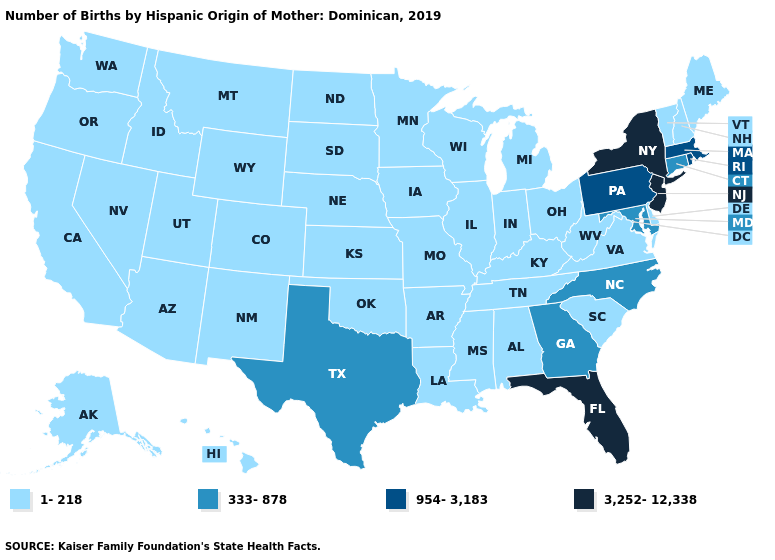Is the legend a continuous bar?
Give a very brief answer. No. Name the states that have a value in the range 954-3,183?
Answer briefly. Massachusetts, Pennsylvania, Rhode Island. What is the value of Oregon?
Be succinct. 1-218. Name the states that have a value in the range 1-218?
Answer briefly. Alabama, Alaska, Arizona, Arkansas, California, Colorado, Delaware, Hawaii, Idaho, Illinois, Indiana, Iowa, Kansas, Kentucky, Louisiana, Maine, Michigan, Minnesota, Mississippi, Missouri, Montana, Nebraska, Nevada, New Hampshire, New Mexico, North Dakota, Ohio, Oklahoma, Oregon, South Carolina, South Dakota, Tennessee, Utah, Vermont, Virginia, Washington, West Virginia, Wisconsin, Wyoming. Which states have the highest value in the USA?
Short answer required. Florida, New Jersey, New York. What is the value of Hawaii?
Concise answer only. 1-218. Is the legend a continuous bar?
Answer briefly. No. Name the states that have a value in the range 1-218?
Write a very short answer. Alabama, Alaska, Arizona, Arkansas, California, Colorado, Delaware, Hawaii, Idaho, Illinois, Indiana, Iowa, Kansas, Kentucky, Louisiana, Maine, Michigan, Minnesota, Mississippi, Missouri, Montana, Nebraska, Nevada, New Hampshire, New Mexico, North Dakota, Ohio, Oklahoma, Oregon, South Carolina, South Dakota, Tennessee, Utah, Vermont, Virginia, Washington, West Virginia, Wisconsin, Wyoming. Does North Carolina have a higher value than Oklahoma?
Quick response, please. Yes. Does the map have missing data?
Quick response, please. No. What is the lowest value in the USA?
Short answer required. 1-218. Does Massachusetts have the highest value in the Northeast?
Quick response, please. No. Name the states that have a value in the range 3,252-12,338?
Keep it brief. Florida, New Jersey, New York. Name the states that have a value in the range 333-878?
Short answer required. Connecticut, Georgia, Maryland, North Carolina, Texas. Name the states that have a value in the range 1-218?
Give a very brief answer. Alabama, Alaska, Arizona, Arkansas, California, Colorado, Delaware, Hawaii, Idaho, Illinois, Indiana, Iowa, Kansas, Kentucky, Louisiana, Maine, Michigan, Minnesota, Mississippi, Missouri, Montana, Nebraska, Nevada, New Hampshire, New Mexico, North Dakota, Ohio, Oklahoma, Oregon, South Carolina, South Dakota, Tennessee, Utah, Vermont, Virginia, Washington, West Virginia, Wisconsin, Wyoming. 